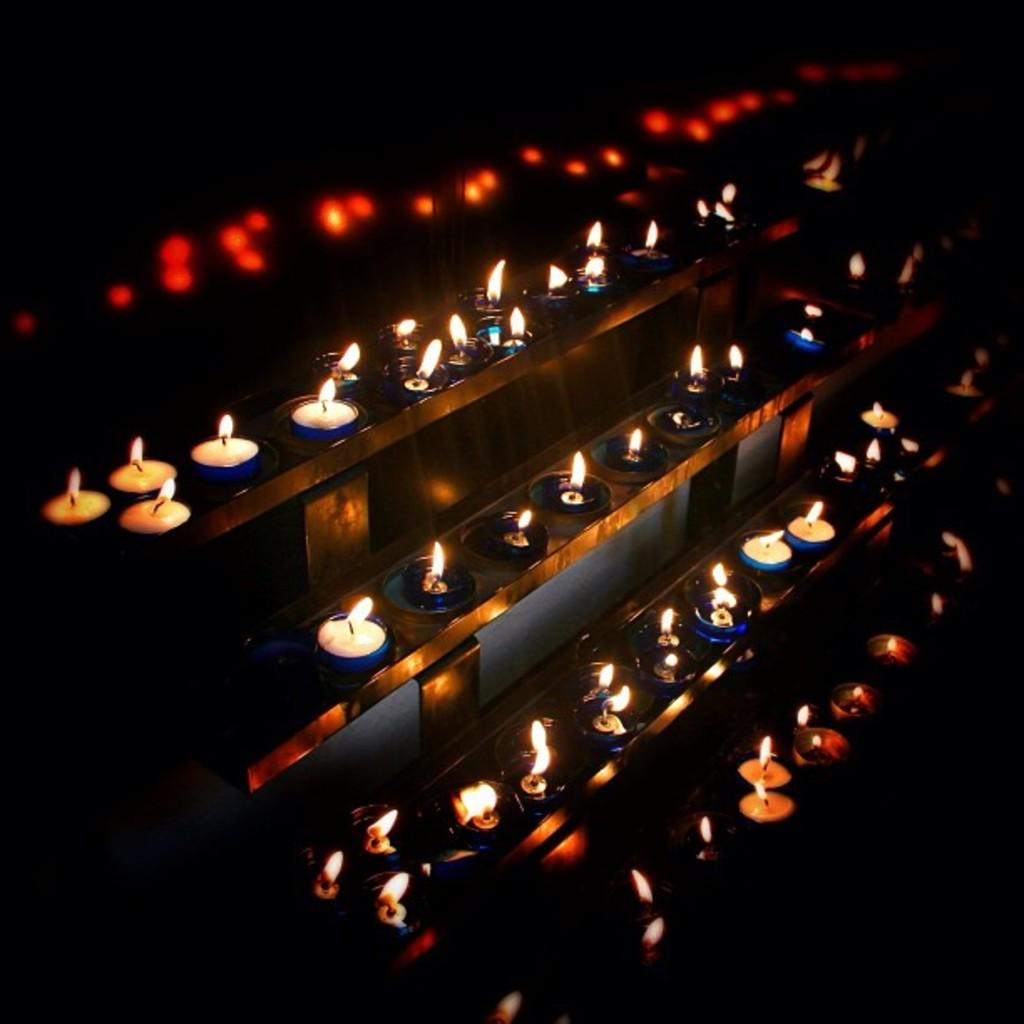What is the main subject of the image? The main subject of the image is a group of candles. How are the candles arranged in the image? The candles are placed on racks in the image. What type of scientific experiment is being conducted with the candles in the image? There is no indication of a scientific experiment in the image; it simply shows a group of candles placed on racks. 